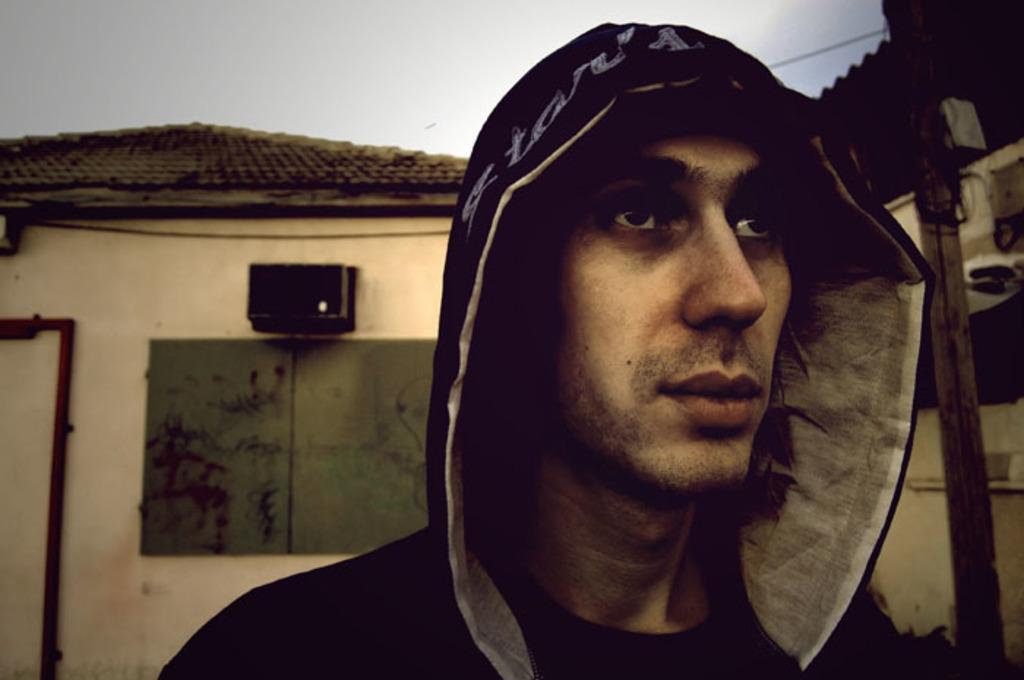How would you summarize this image in a sentence or two? In this image there is a person, behind the person there is a house. 